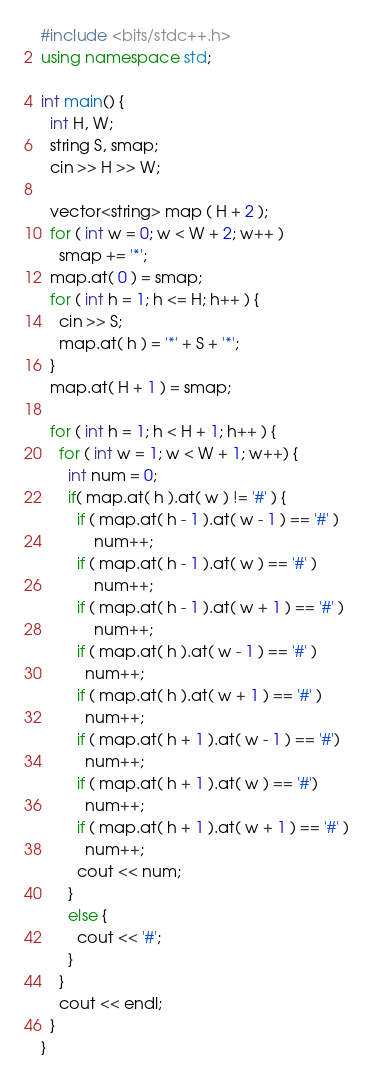Convert code to text. <code><loc_0><loc_0><loc_500><loc_500><_C++_>#include <bits/stdc++.h>
using namespace std;
  
int main() {
  int H, W;
  string S, smap;
  cin >> H >> W;

  vector<string> map ( H + 2 );
  for ( int w = 0; w < W + 2; w++ ) 
    smap += '*';
  map.at( 0 ) = smap;
  for ( int h = 1; h <= H; h++ ) {
    cin >> S;
    map.at( h ) = '*' + S + '*';
  }
  map.at( H + 1 ) = smap;

  for ( int h = 1; h < H + 1; h++ ) {
    for ( int w = 1; w < W + 1; w++) {
      int num = 0;
      if( map.at( h ).at( w ) != '#' ) {
        if ( map.at( h - 1 ).at( w - 1 ) == '#' )
            num++;
        if ( map.at( h - 1 ).at( w ) == '#' )
            num++;
        if ( map.at( h - 1 ).at( w + 1 ) == '#' )
            num++;
        if ( map.at( h ).at( w - 1 ) == '#' )
          num++;
        if ( map.at( h ).at( w + 1 ) == '#' )
          num++;
        if ( map.at( h + 1 ).at( w - 1 ) == '#')
          num++;
        if ( map.at( h + 1 ).at( w ) == '#')
          num++;
        if ( map.at( h + 1 ).at( w + 1 ) == '#' )
          num++;     
        cout << num;
      }
      else {
        cout << '#';
      }
    }
    cout << endl;
  }
}
</code> 